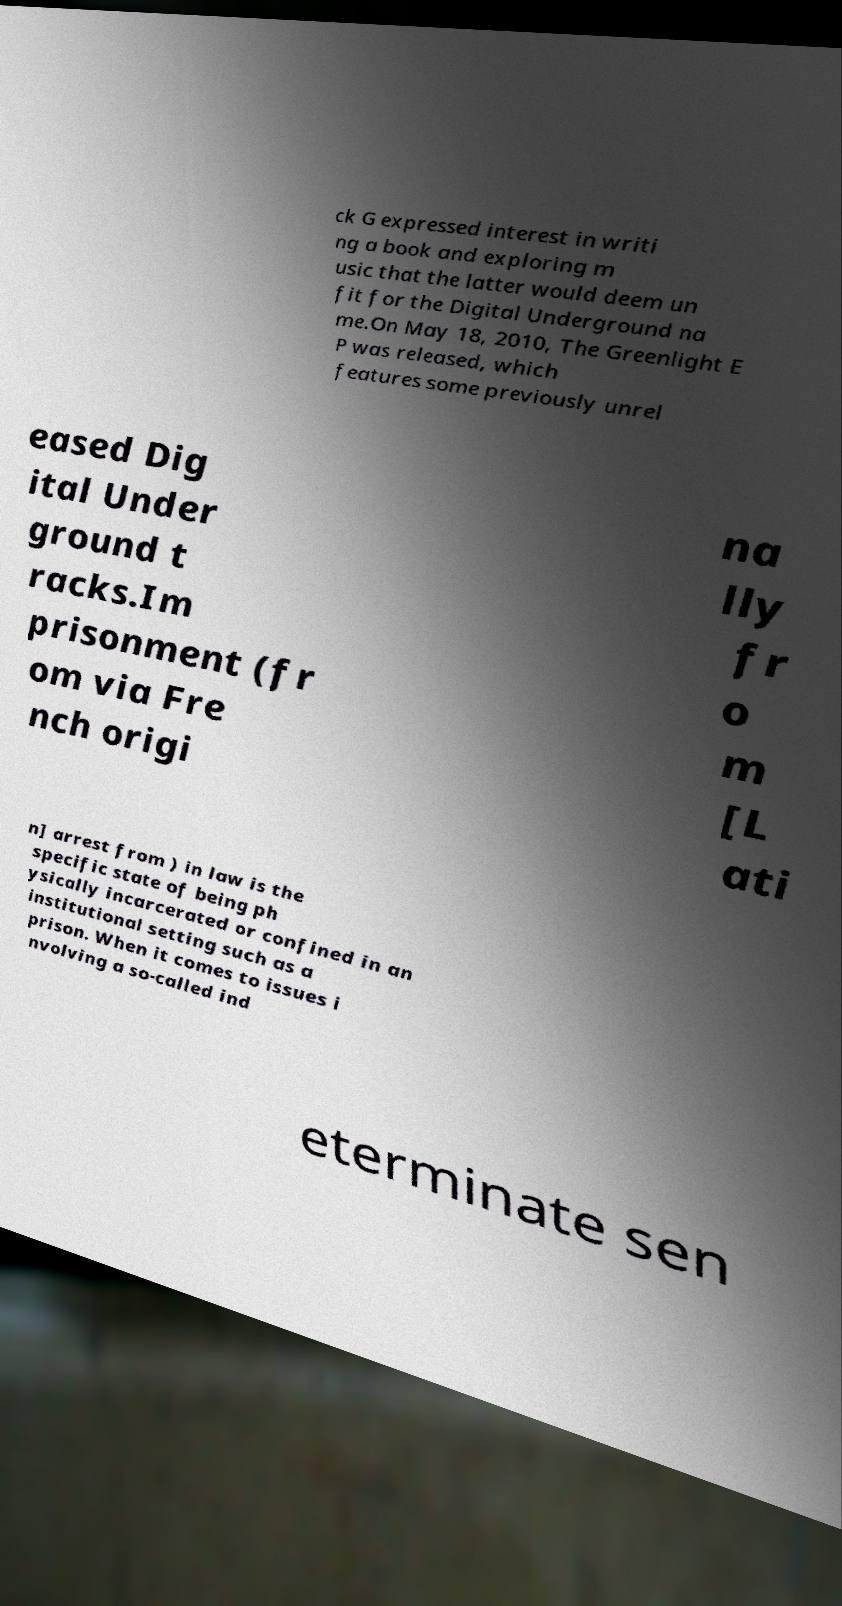Could you assist in decoding the text presented in this image and type it out clearly? ck G expressed interest in writi ng a book and exploring m usic that the latter would deem un fit for the Digital Underground na me.On May 18, 2010, The Greenlight E P was released, which features some previously unrel eased Dig ital Under ground t racks.Im prisonment (fr om via Fre nch origi na lly fr o m [L ati n] arrest from ) in law is the specific state of being ph ysically incarcerated or confined in an institutional setting such as a prison. When it comes to issues i nvolving a so-called ind eterminate sen 